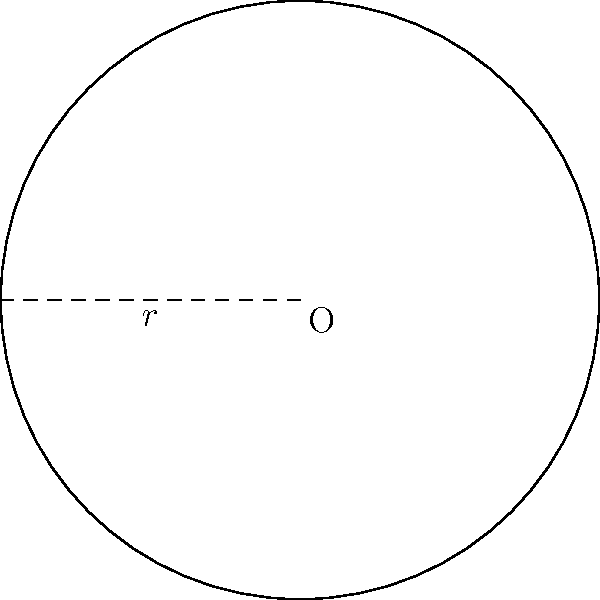As a cricket enthusiast, you're curious about the playing area of a circular cricket field. If the radius of the field is 70 meters, what is the total area of the field in square meters? (Use $\pi = 3.14$ for your calculations) To find the area of a circular cricket field, we need to use the formula for the area of a circle:

1. The formula for the area of a circle is $A = \pi r^2$, where $A$ is the area and $r$ is the radius.

2. We are given that the radius $r = 70$ meters and $\pi = 3.14$.

3. Let's substitute these values into the formula:
   $A = 3.14 \times 70^2$

4. First, calculate $70^2$:
   $70^2 = 4,900$

5. Now, multiply by $3.14$:
   $A = 3.14 \times 4,900 = 15,386$

Therefore, the total area of the circular cricket field is 15,386 square meters.
Answer: 15,386 square meters 